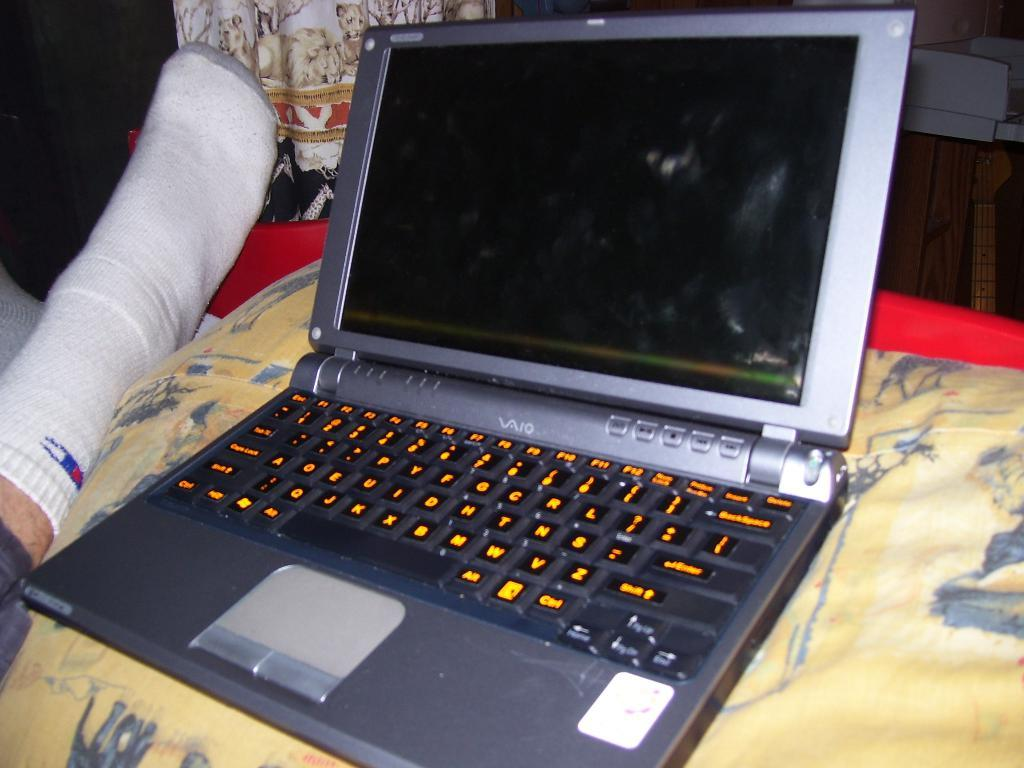What electronic device is present in the image? There is a laptop in the image. What color is the laptop? The laptop is grey in color. Can you describe any other elements in the image? There is a human leg visible in the image. How much payment is required to use the laptop in the image? There is no information about payment or any transaction related to the laptop in the image. 